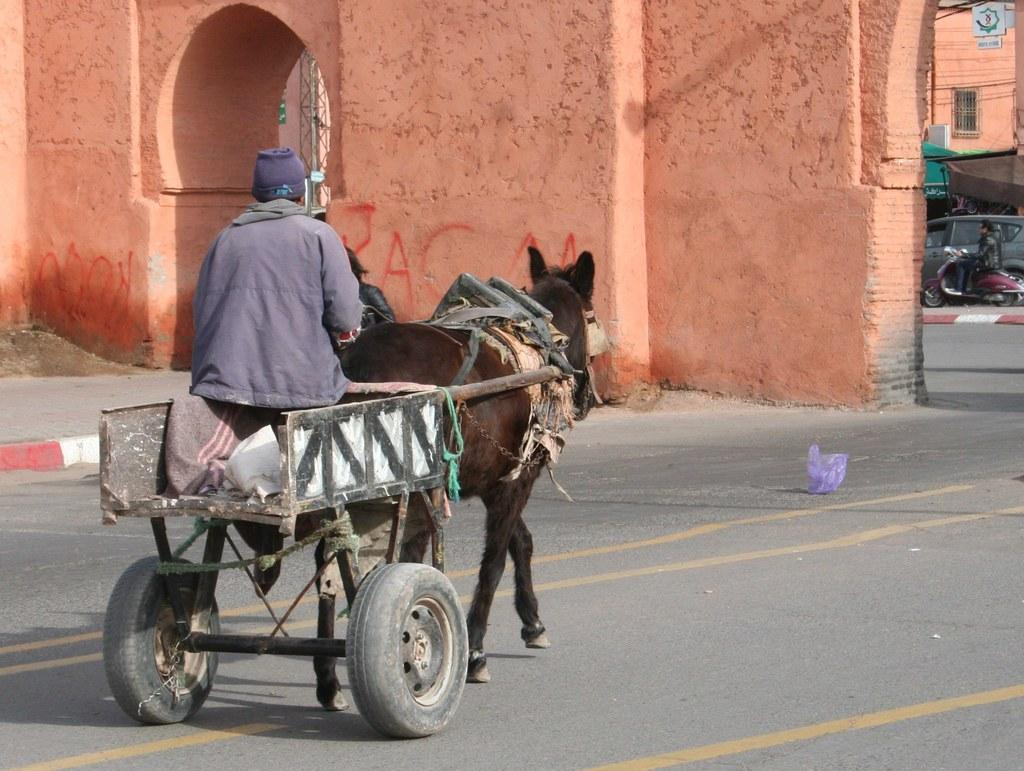What is the man in the image doing? The man is riding a cart and sitting on a horse. What can be seen in the background of the image? There is a wall, an arch, and a car in the background of the image. How many pizzas are on top of the linen in the image? There are no pizzas or linen present in the image. 